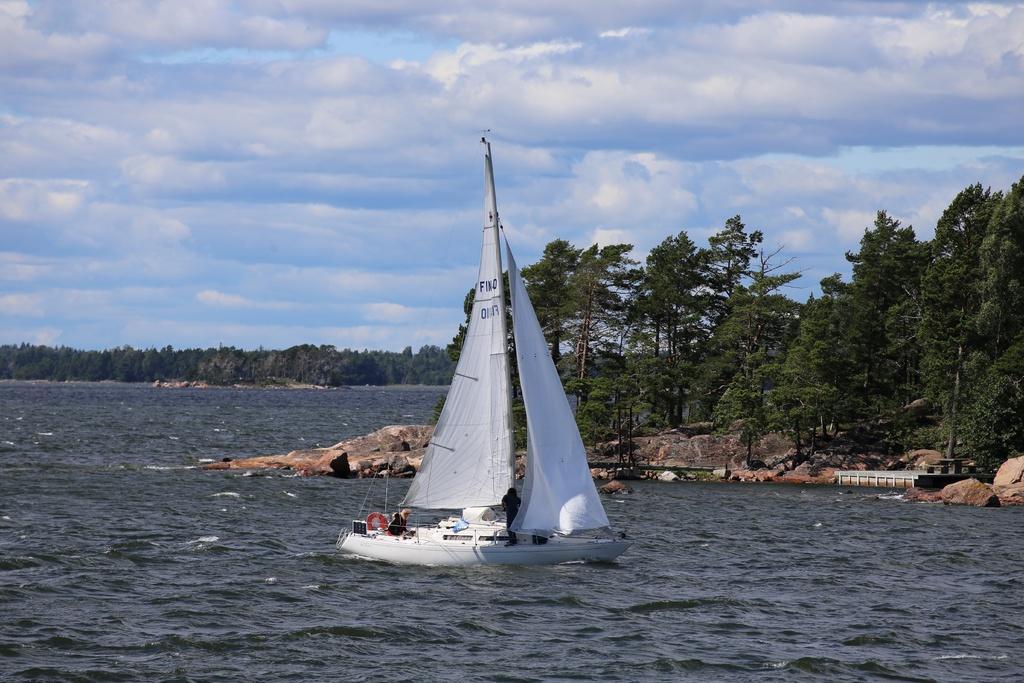Can you describe this image briefly? In this image there is a boat on the water, there are trees, and in the background there is sky. 